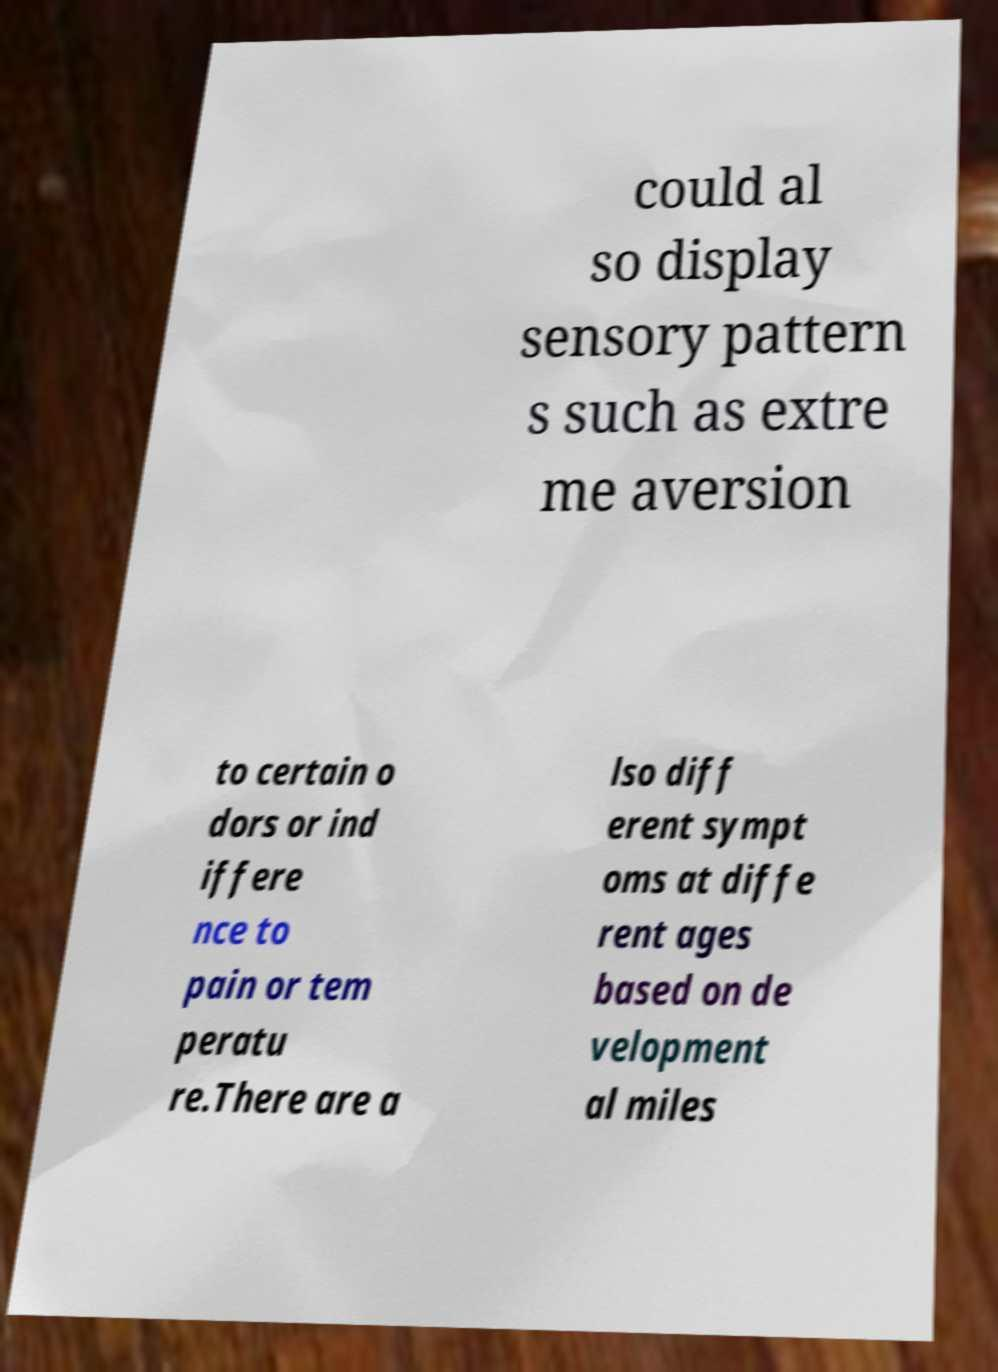What messages or text are displayed in this image? I need them in a readable, typed format. could al so display sensory pattern s such as extre me aversion to certain o dors or ind iffere nce to pain or tem peratu re.There are a lso diff erent sympt oms at diffe rent ages based on de velopment al miles 